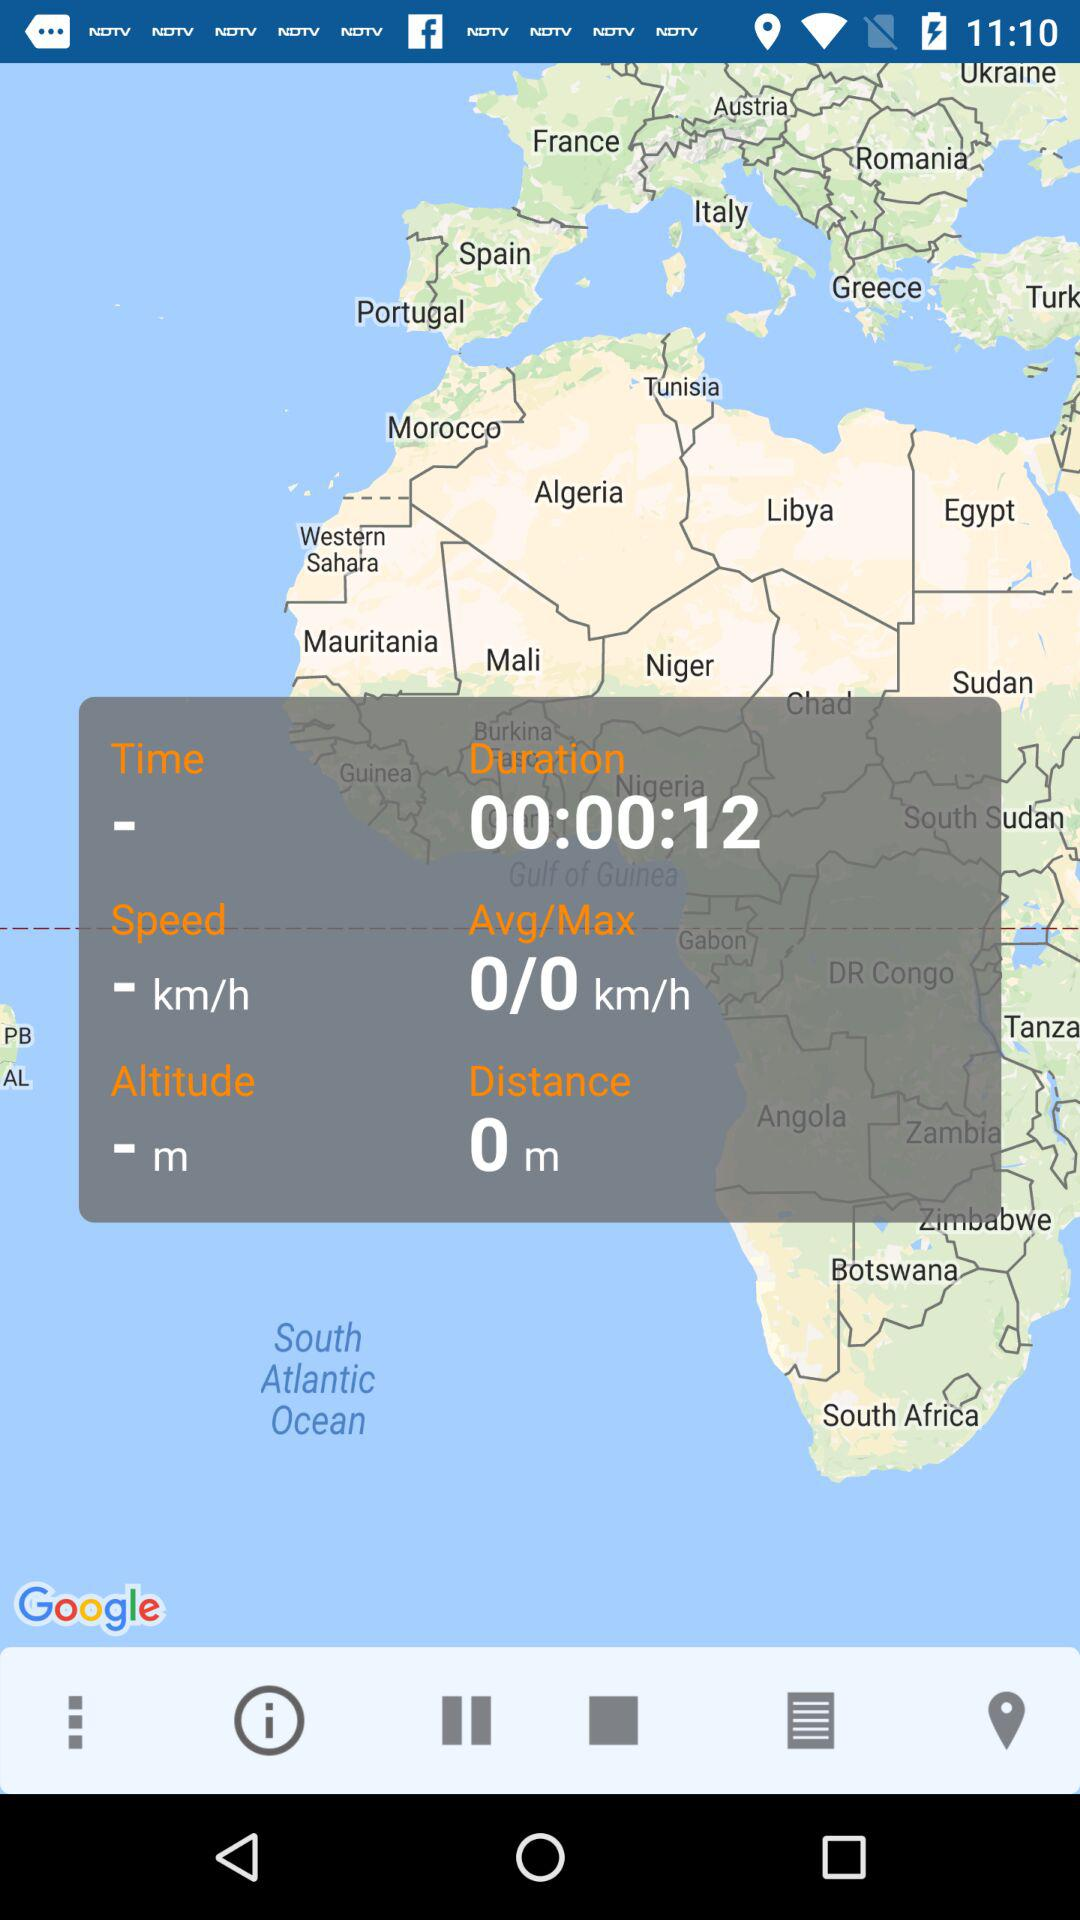What is the average speed of the trip?
Answer the question using a single word or phrase. 0 